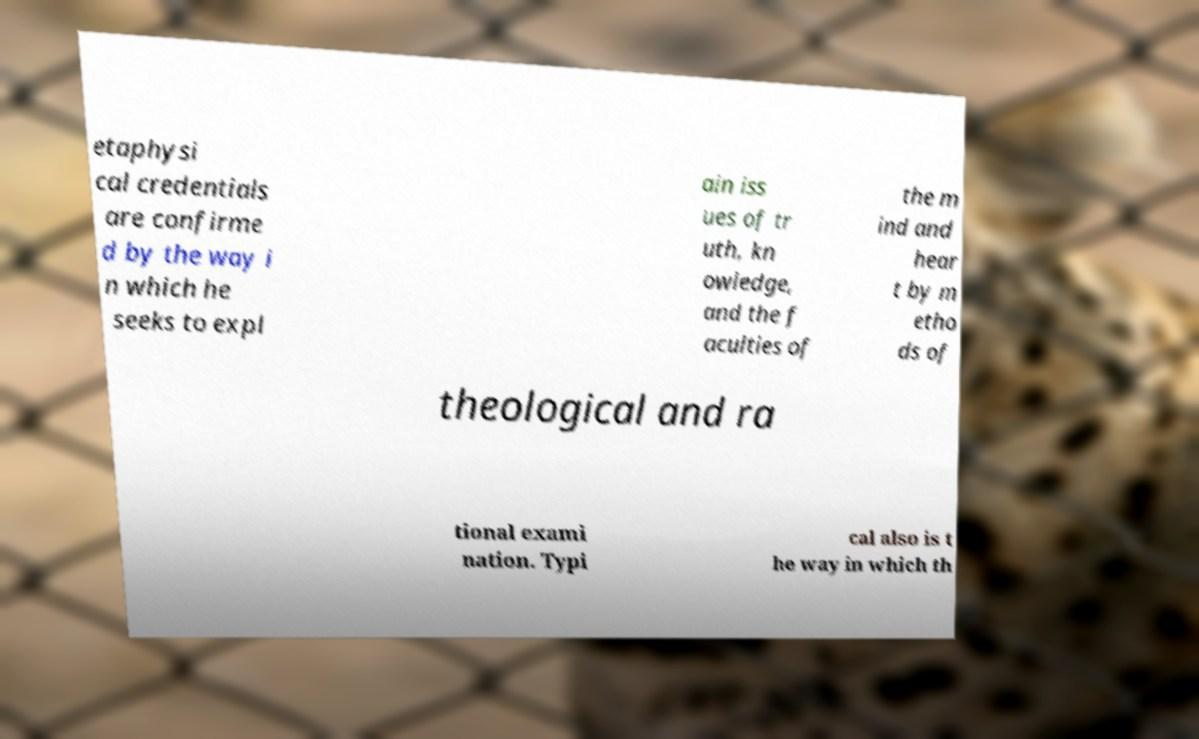Please identify and transcribe the text found in this image. etaphysi cal credentials are confirme d by the way i n which he seeks to expl ain iss ues of tr uth, kn owledge, and the f aculties of the m ind and hear t by m etho ds of theological and ra tional exami nation. Typi cal also is t he way in which th 